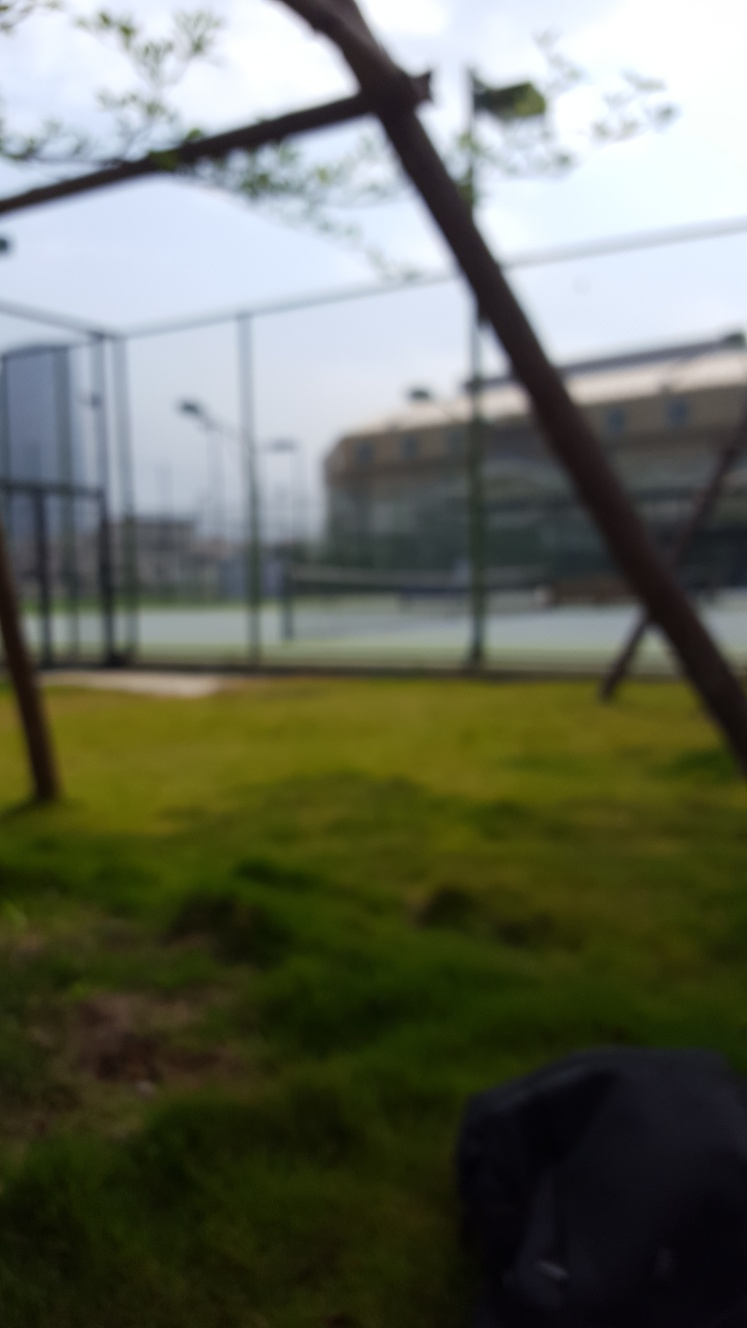Can you describe the setting or environment depicted in this blurred image? Despite the image being out of focus, it appears to portray an outdoor scene possibly within an urban park setting. There are glimpses of what could be grassy areas in the foreground, a backdrop that might include recreational courts for sports, and structures that could be lamp posts or trees, all contributing to the impression of a public outdoor space. 